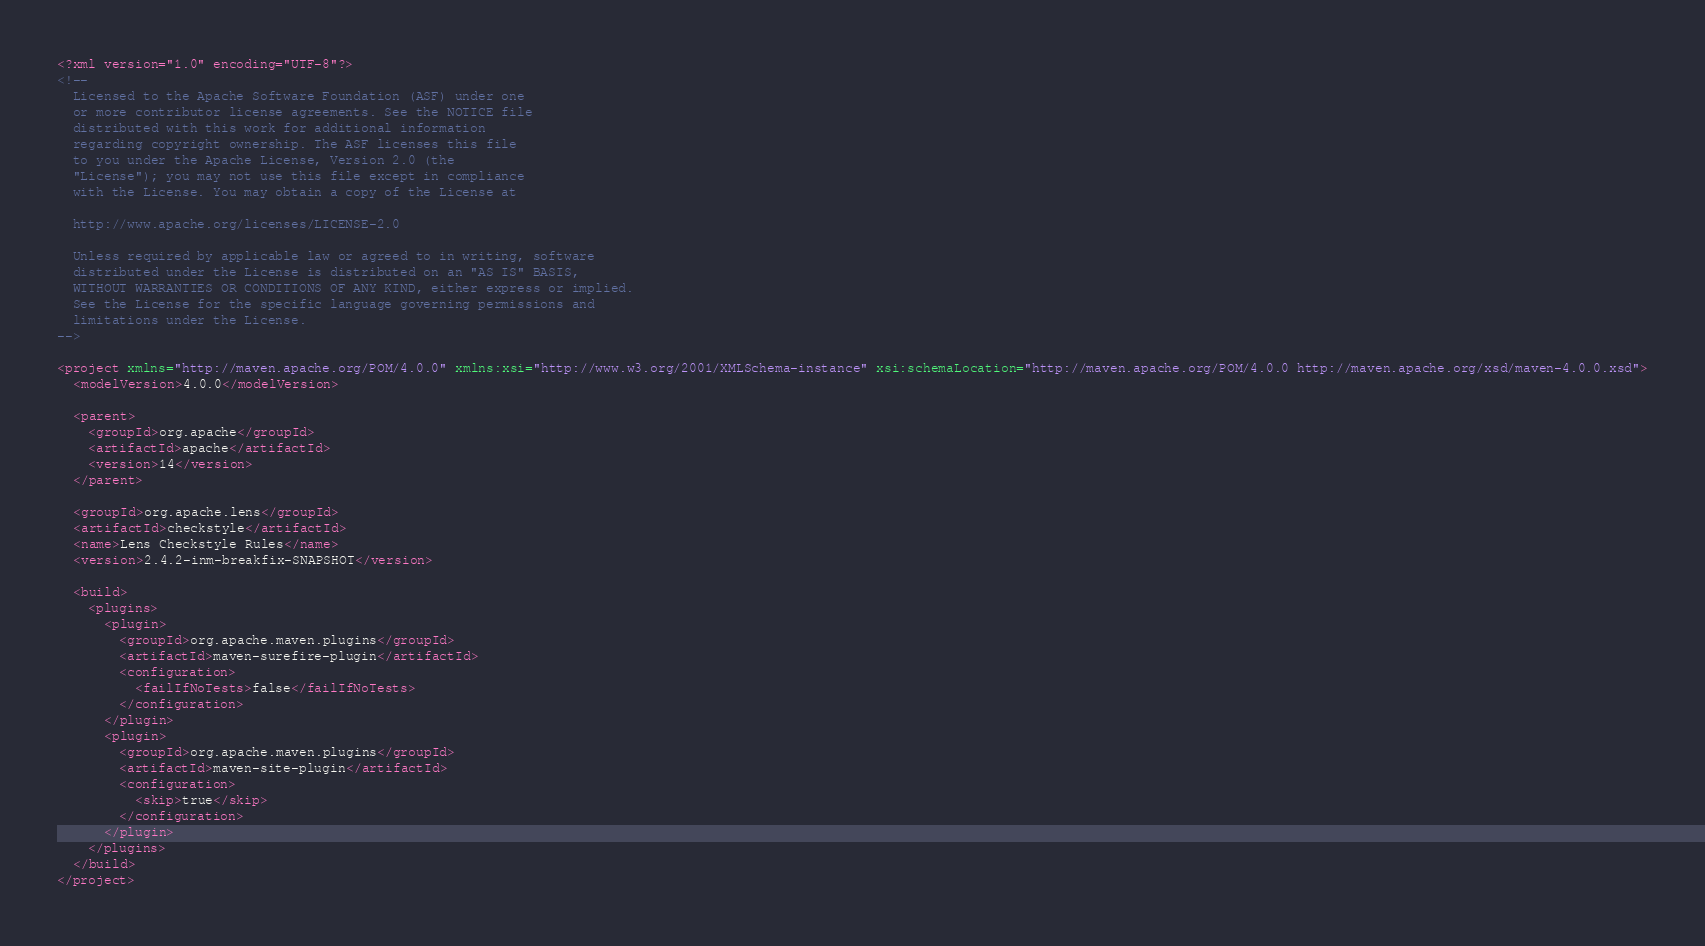<code> <loc_0><loc_0><loc_500><loc_500><_XML_><?xml version="1.0" encoding="UTF-8"?>
<!--
  Licensed to the Apache Software Foundation (ASF) under one
  or more contributor license agreements. See the NOTICE file
  distributed with this work for additional information
  regarding copyright ownership. The ASF licenses this file
  to you under the Apache License, Version 2.0 (the
  "License"); you may not use this file except in compliance
  with the License. You may obtain a copy of the License at

  http://www.apache.org/licenses/LICENSE-2.0

  Unless required by applicable law or agreed to in writing, software
  distributed under the License is distributed on an "AS IS" BASIS,
  WITHOUT WARRANTIES OR CONDITIONS OF ANY KIND, either express or implied.
  See the License for the specific language governing permissions and
  limitations under the License.
-->

<project xmlns="http://maven.apache.org/POM/4.0.0" xmlns:xsi="http://www.w3.org/2001/XMLSchema-instance" xsi:schemaLocation="http://maven.apache.org/POM/4.0.0 http://maven.apache.org/xsd/maven-4.0.0.xsd">
  <modelVersion>4.0.0</modelVersion>

  <parent>
    <groupId>org.apache</groupId>
    <artifactId>apache</artifactId>
    <version>14</version>
  </parent>

  <groupId>org.apache.lens</groupId>
  <artifactId>checkstyle</artifactId>
  <name>Lens Checkstyle Rules</name>
  <version>2.4.2-inm-breakfix-SNAPSHOT</version>

  <build>
    <plugins>
      <plugin>
        <groupId>org.apache.maven.plugins</groupId>
        <artifactId>maven-surefire-plugin</artifactId>
        <configuration>
          <failIfNoTests>false</failIfNoTests>
        </configuration>
      </plugin>
      <plugin>
        <groupId>org.apache.maven.plugins</groupId>
        <artifactId>maven-site-plugin</artifactId>
        <configuration>
          <skip>true</skip>
        </configuration>
      </plugin>
    </plugins>
  </build>
</project>
</code> 